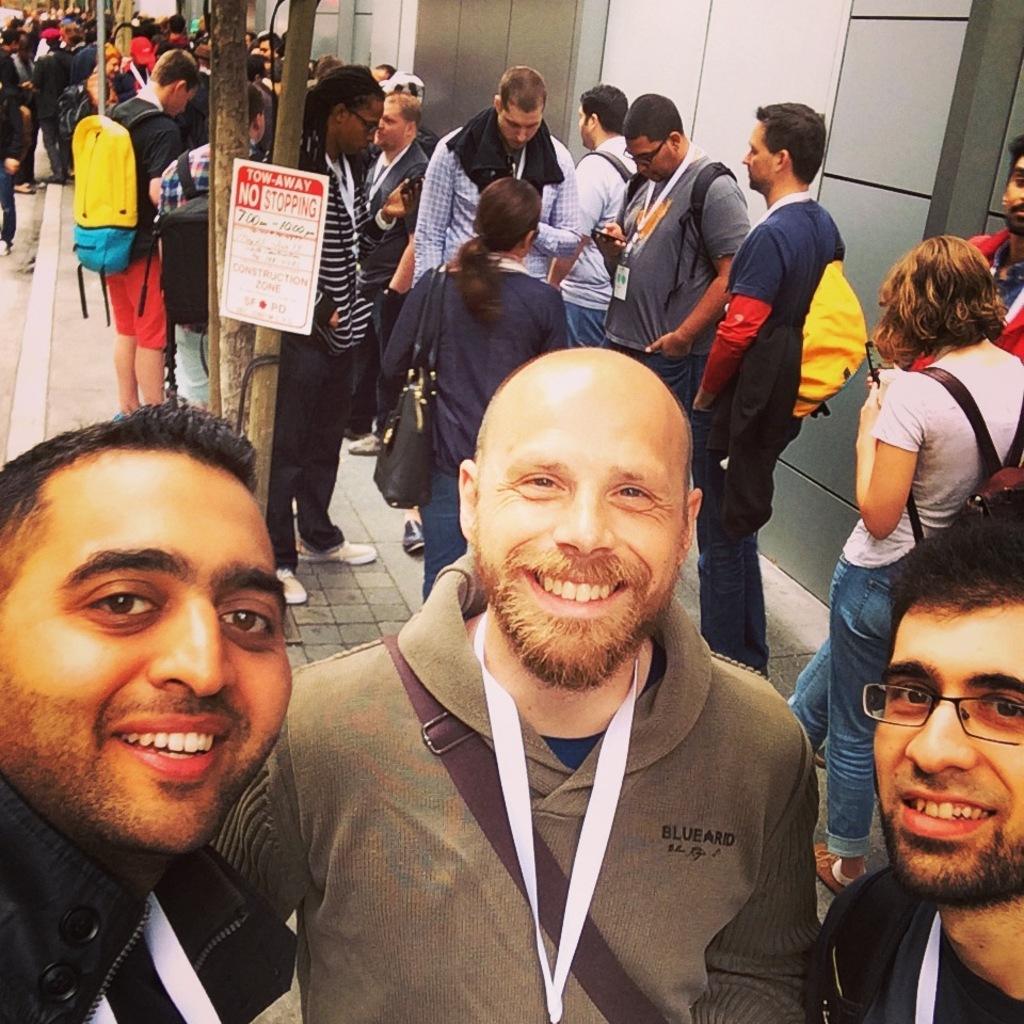In one or two sentences, can you explain what this image depicts? In this image I can see group of people standing. The person in front wearing brown shirt, white color tag, background I can see a building in gray color and I can also see a white color board attached to the tree. 